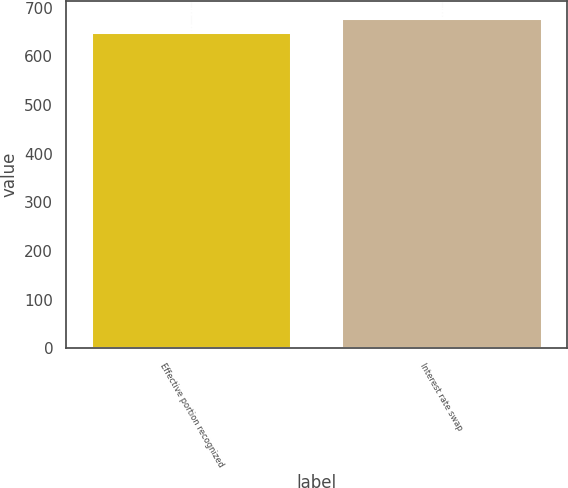Convert chart to OTSL. <chart><loc_0><loc_0><loc_500><loc_500><bar_chart><fcel>Effective portion recognized<fcel>Interest rate swap<nl><fcel>649<fcel>679<nl></chart> 